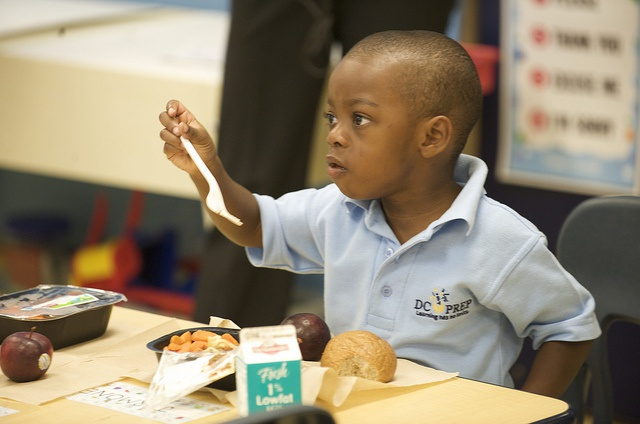Describe the objects in this image and their specific colors. I can see people in lightgray, darkgray, maroon, and olive tones, dining table in lightgray, khaki, beige, tan, and black tones, chair in lightgray, black, and gray tones, bowl in lightgray, black, darkgray, and tan tones, and apple in lightgray, maroon, and brown tones in this image. 